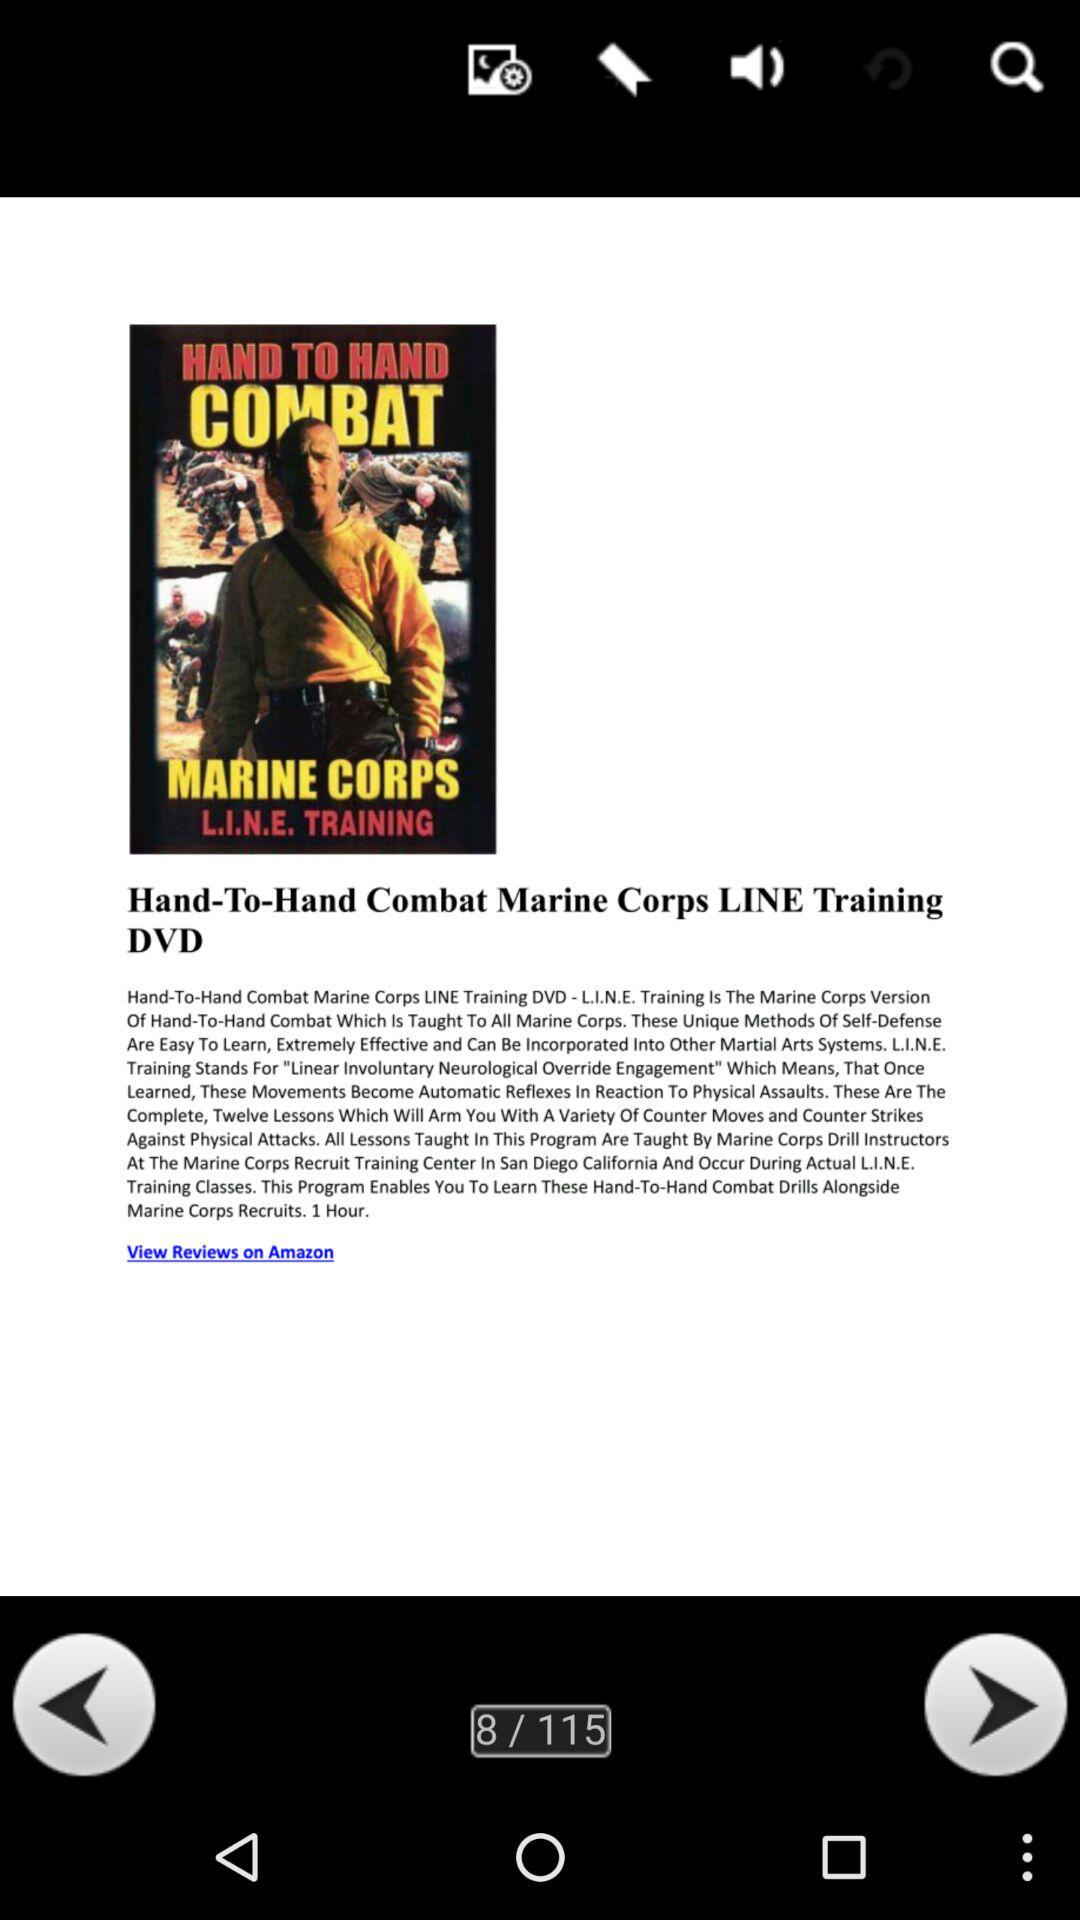How many Amazon reviews does the Marine Corps training DVD have?
When the provided information is insufficient, respond with <no answer>. <no answer> 